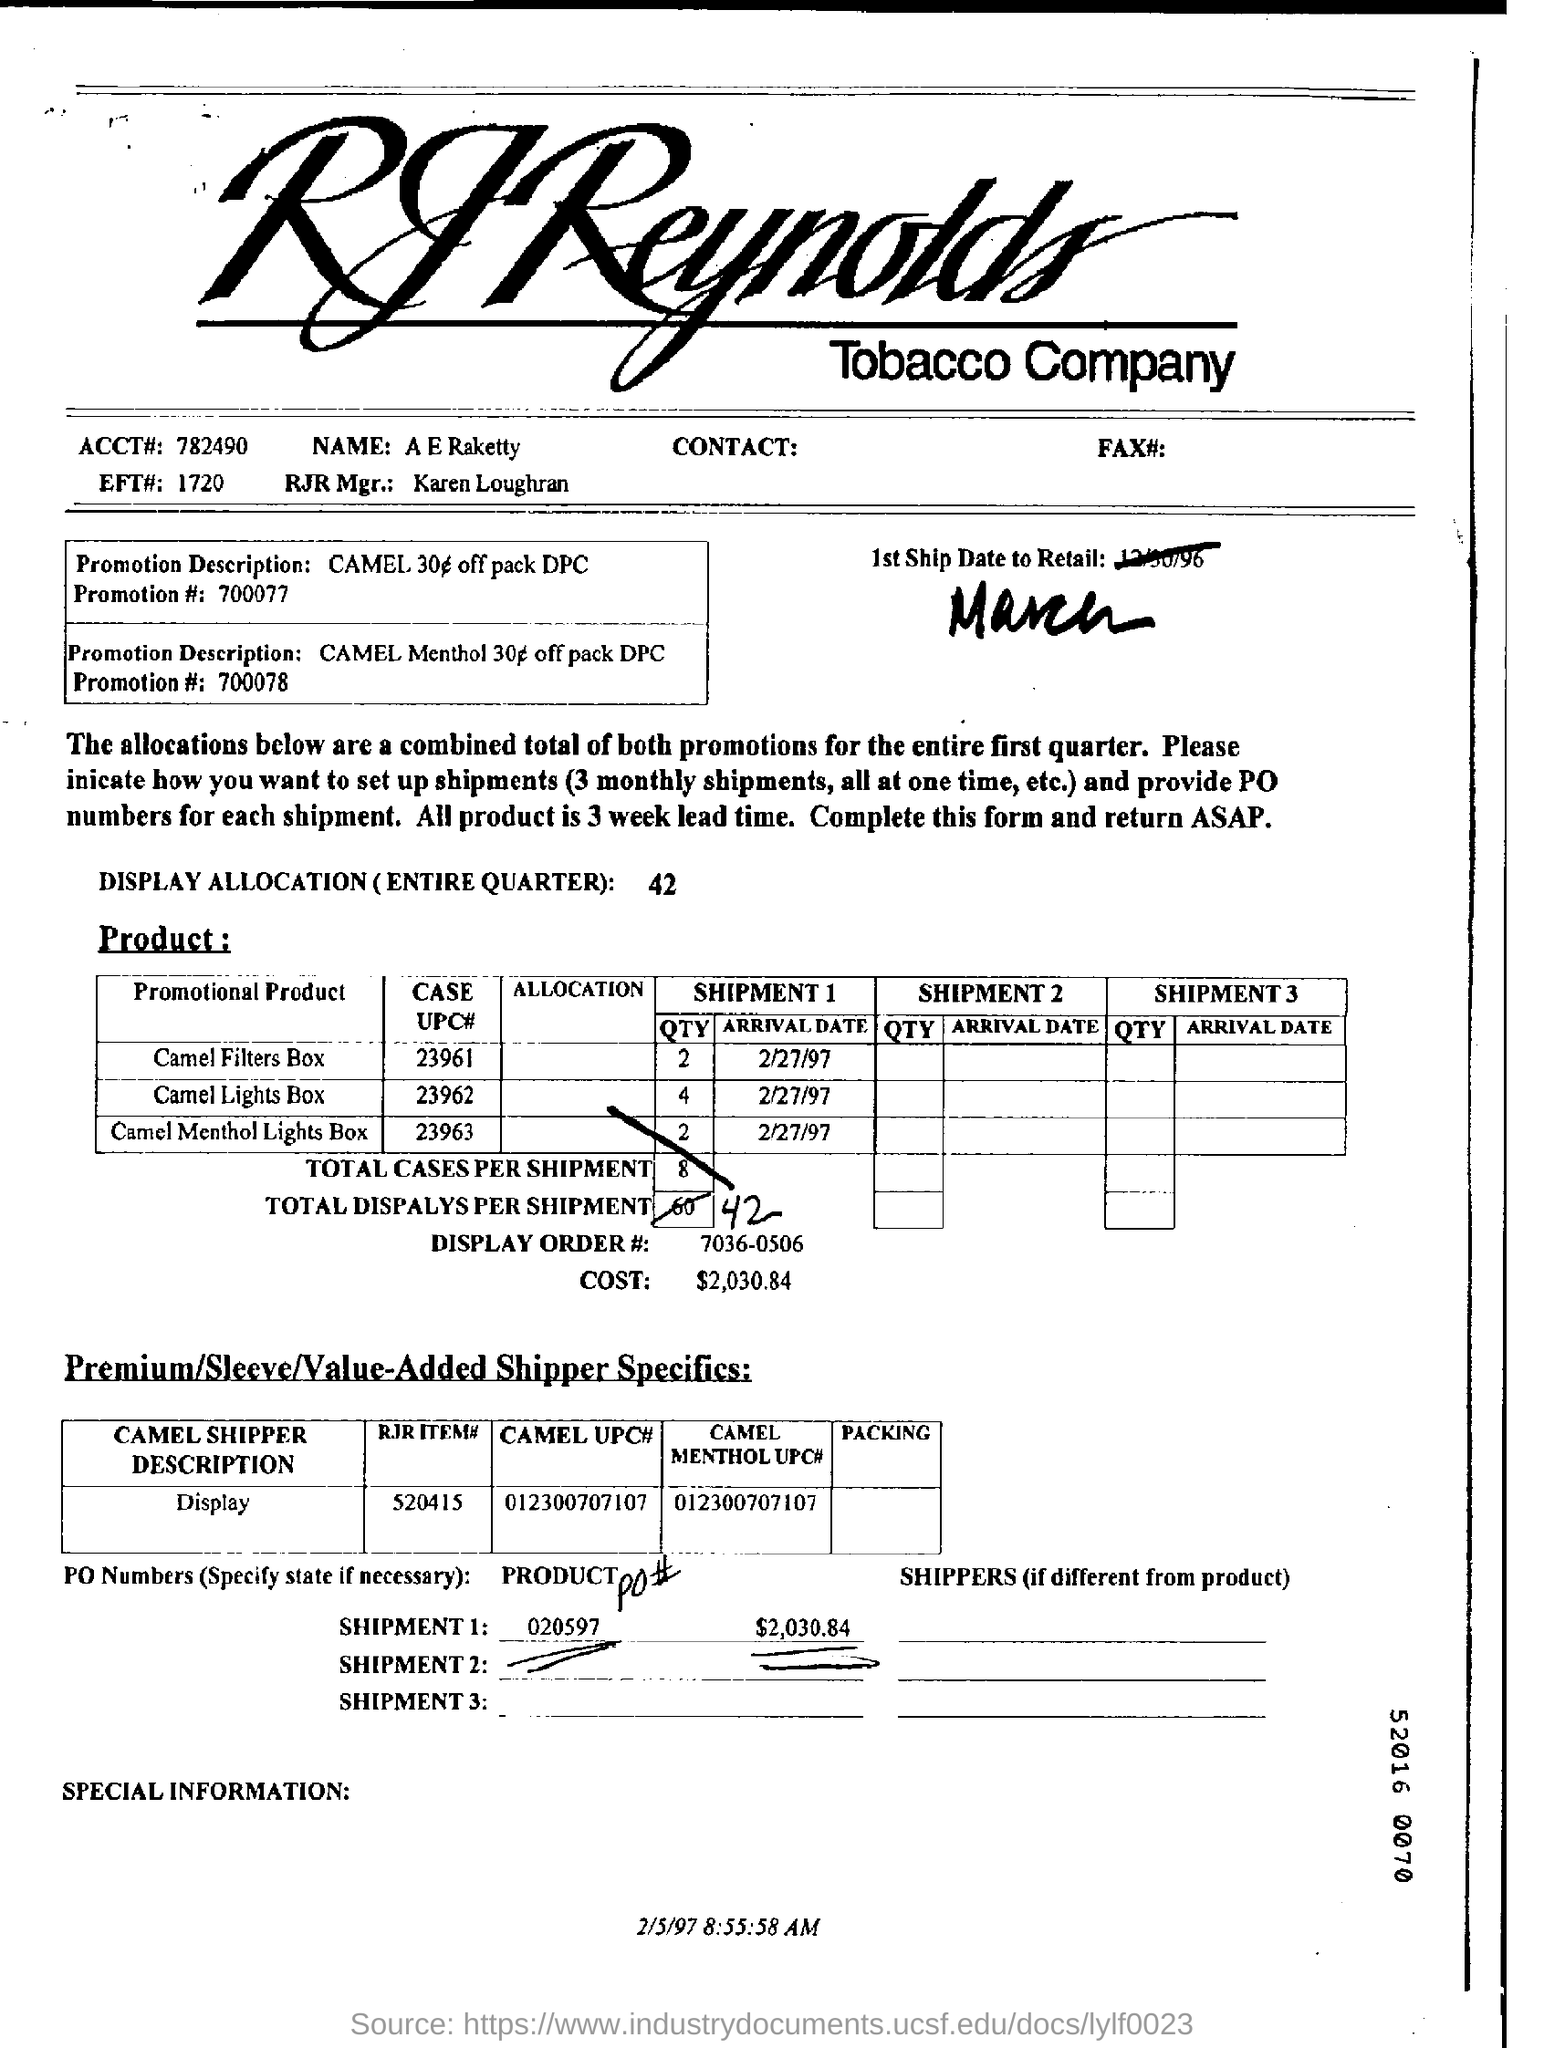Draw attention to some important aspects in this diagram. Karen Loughran is the manager of RJR. The number of cases per shipment is mentioned in the form. In total, there are 8 of them. The total cost for shipment 1 is $2,030.84. What is the total display allocation for the entire quarter? It is 42... The form is dated as of 2/5/97. 